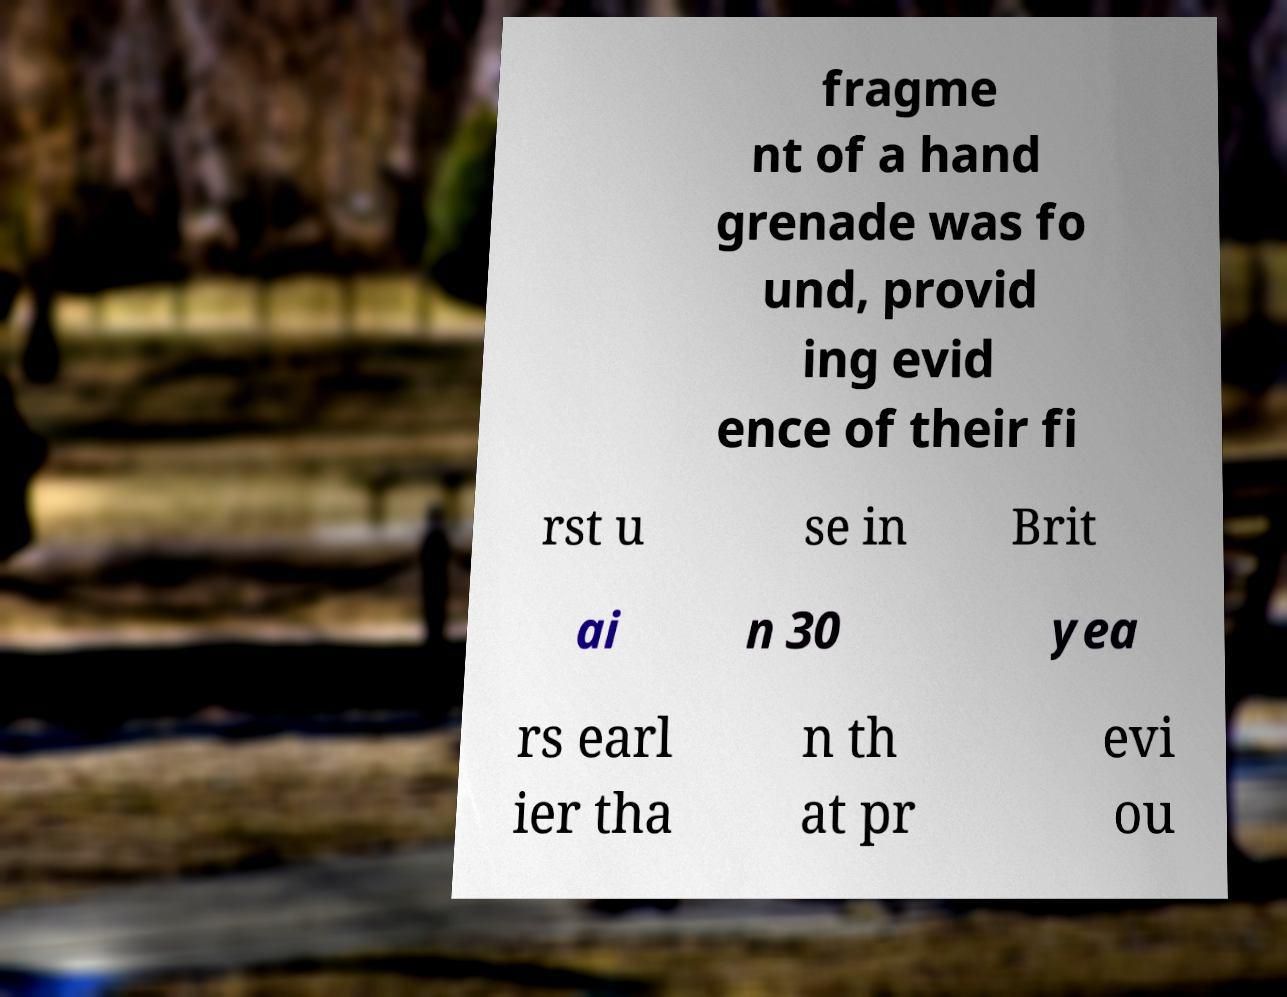Can you read and provide the text displayed in the image?This photo seems to have some interesting text. Can you extract and type it out for me? fragme nt of a hand grenade was fo und, provid ing evid ence of their fi rst u se in Brit ai n 30 yea rs earl ier tha n th at pr evi ou 